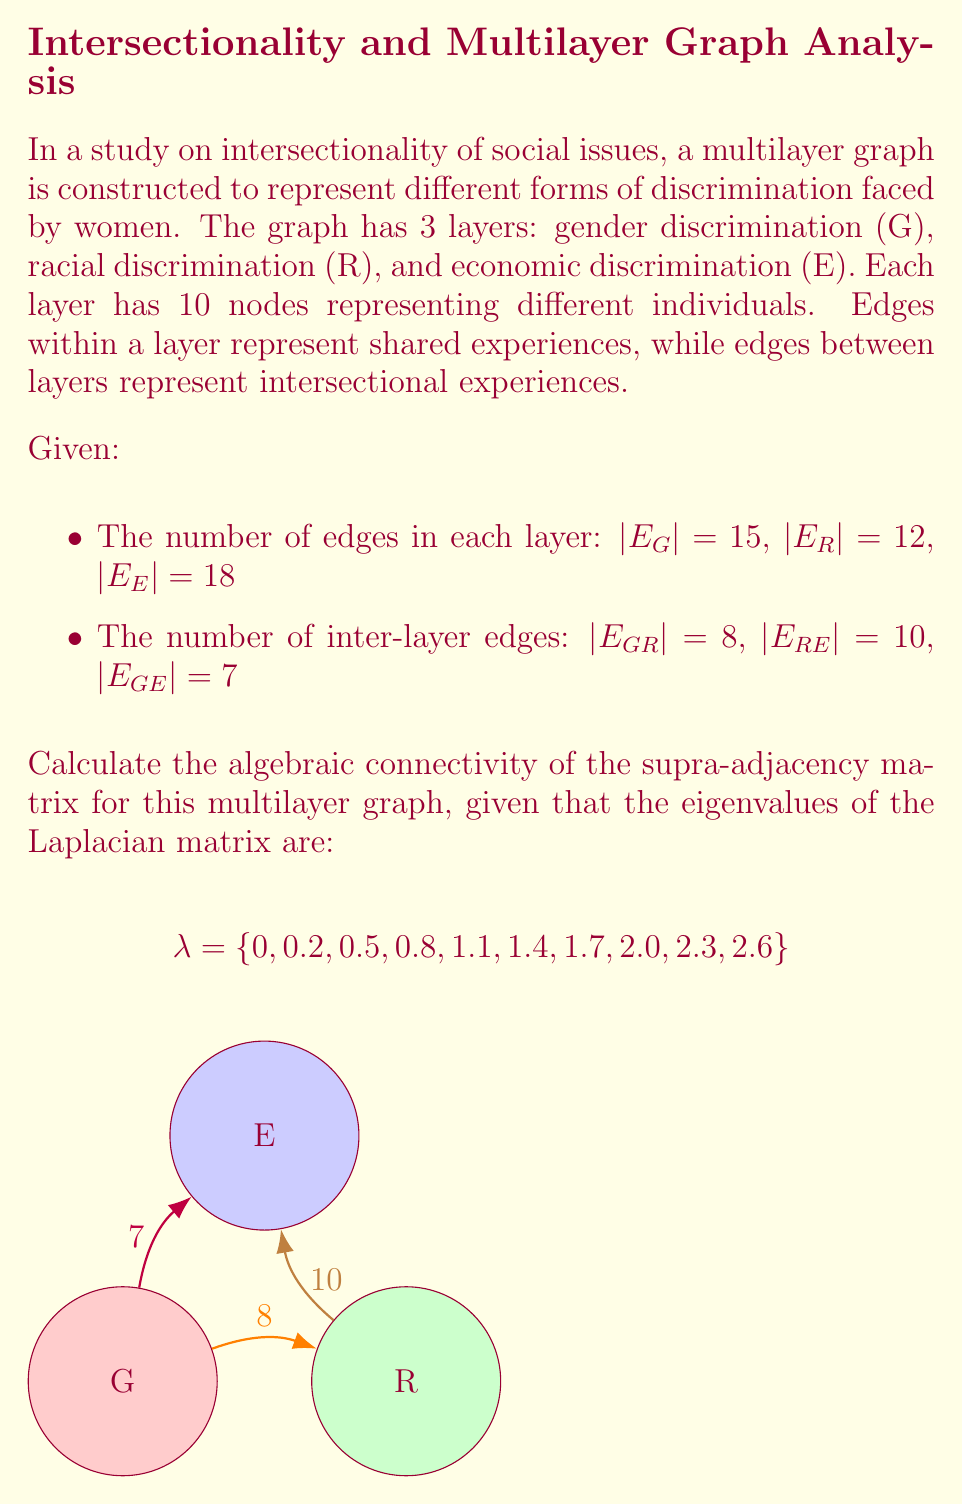Show me your answer to this math problem. To solve this problem, we need to understand the concept of algebraic connectivity in multilayer graphs and how to calculate it using the Laplacian matrix. Let's break it down step-by-step:

1) The supra-adjacency matrix for a multilayer graph combines the adjacency matrices of individual layers and the inter-layer connections. The Laplacian matrix is derived from this supra-adjacency matrix.

2) The algebraic connectivity of a graph is defined as the second smallest eigenvalue of the Laplacian matrix. This value is also known as the Fiedler value.

3) In our case, we are given the eigenvalues of the Laplacian matrix:

   $$\lambda = \{0, 0.2, 0.5, 0.8, 1.1, 1.4, 1.7, 2.0, 2.3, 2.6\}$$

4) The eigenvalues are typically arranged in ascending order. The smallest eigenvalue of a Laplacian matrix is always 0, which corresponds to the first value in our set.

5) The algebraic connectivity is the second smallest eigenvalue, which in this case is 0.2.

6) This value (0.2) represents the algebraic connectivity of the multilayer graph, indicating how well-connected the graph is across all layers. A higher value would indicate stronger connectivity and more robust intersectionality in the represented social issues.

Note: The actual construction of the Laplacian matrix and calculation of eigenvalues are complex processes that depend on the specific structure of the graph. In this case, we're given the eigenvalues directly, simplifying our task to identifying the correct value.
Answer: 0.2 